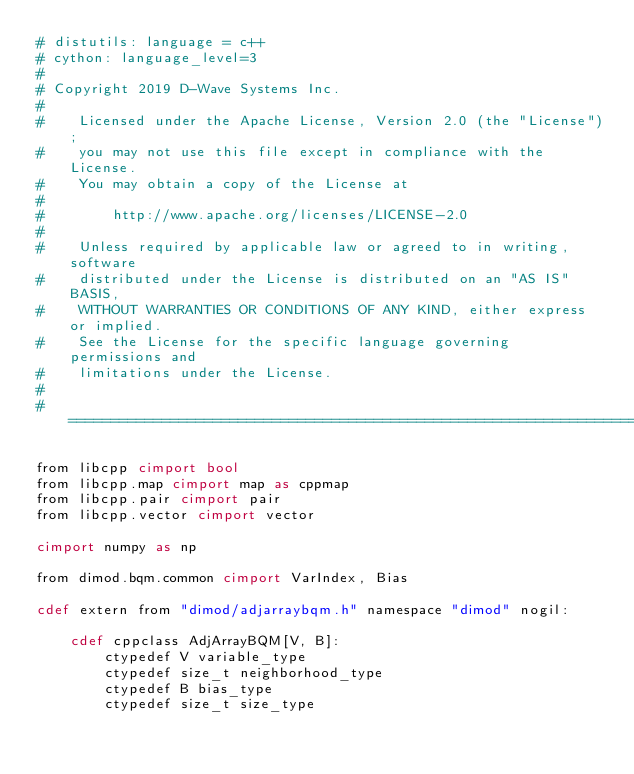Convert code to text. <code><loc_0><loc_0><loc_500><loc_500><_Cython_># distutils: language = c++
# cython: language_level=3
#
# Copyright 2019 D-Wave Systems Inc.
#
#    Licensed under the Apache License, Version 2.0 (the "License");
#    you may not use this file except in compliance with the License.
#    You may obtain a copy of the License at
#
#        http://www.apache.org/licenses/LICENSE-2.0
#
#    Unless required by applicable law or agreed to in writing, software
#    distributed under the License is distributed on an "AS IS" BASIS,
#    WITHOUT WARRANTIES OR CONDITIONS OF ANY KIND, either express or implied.
#    See the License for the specific language governing permissions and
#    limitations under the License.
#
# =============================================================================

from libcpp cimport bool
from libcpp.map cimport map as cppmap
from libcpp.pair cimport pair
from libcpp.vector cimport vector

cimport numpy as np

from dimod.bqm.common cimport VarIndex, Bias

cdef extern from "dimod/adjarraybqm.h" namespace "dimod" nogil:

    cdef cppclass AdjArrayBQM[V, B]:
        ctypedef V variable_type
        ctypedef size_t neighborhood_type
        ctypedef B bias_type
        ctypedef size_t size_type
</code> 